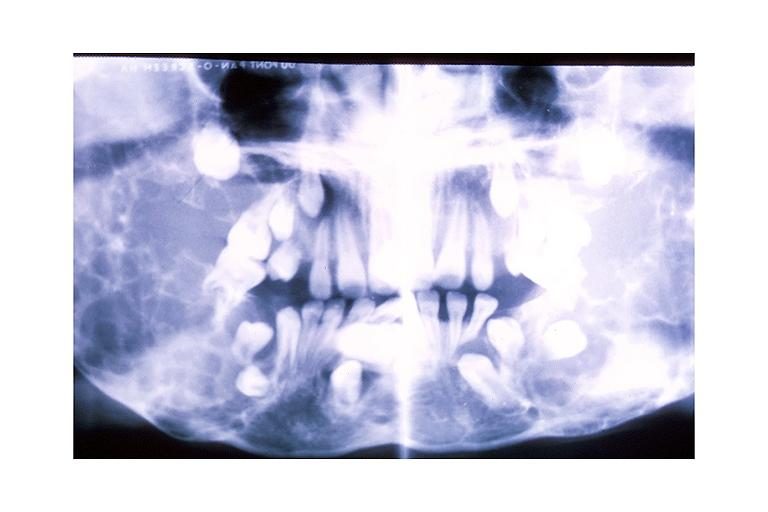where is this?
Answer the question using a single word or phrase. Oral 